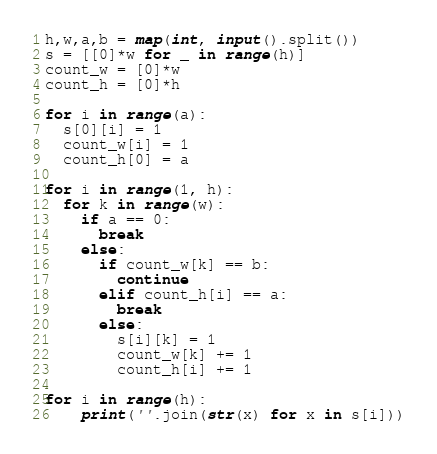<code> <loc_0><loc_0><loc_500><loc_500><_Python_>h,w,a,b = map(int, input().split())
s = [[0]*w for _ in range(h)]
count_w = [0]*w
count_h = [0]*h

for i in range(a):
  s[0][i] = 1
  count_w[i] = 1
  count_h[0] = a

for i in range(1, h):
  for k in range(w):
    if a == 0:
      break
    else:
      if count_w[k] == b:
        continue
      elif count_h[i] == a:
        break
      else:
        s[i][k] = 1
        count_w[k] += 1
        count_h[i] += 1
        
for i in range(h):
	print(''.join(str(x) for x in s[i]))

</code> 